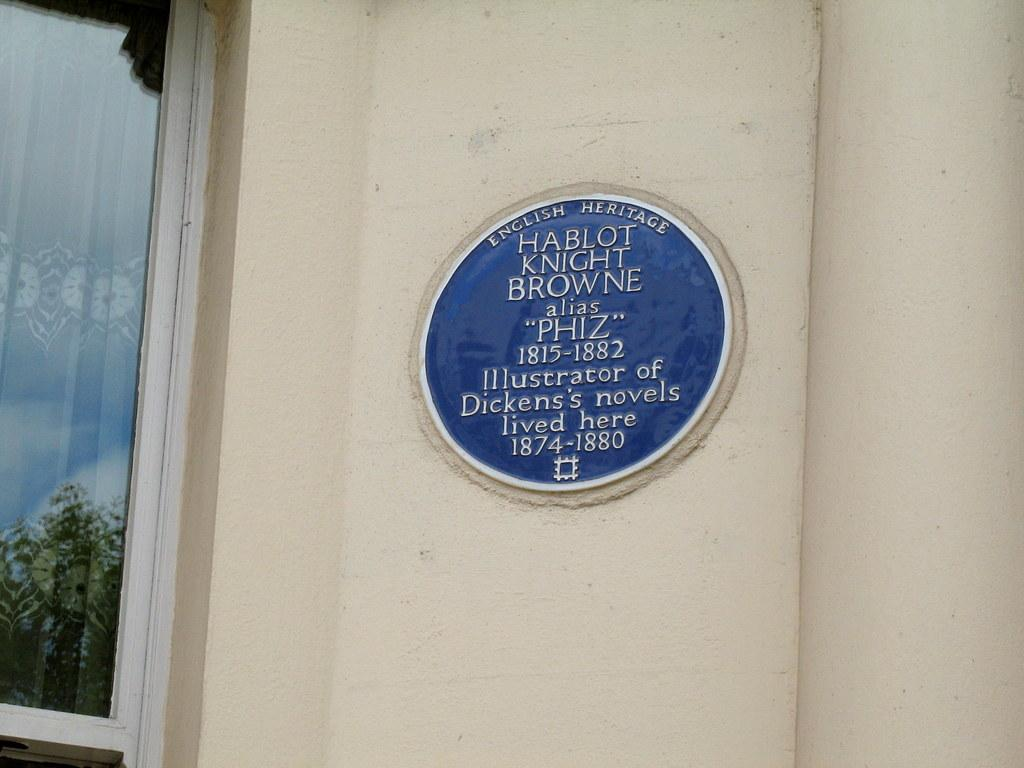What is the main structure in the image? There is a wall in the image. What is located in the middle of the wall? There is a carved stone in the middle of the wall. What object is on the left side of the wall? There is a glass on the left side of the wall. What can be seen in the glass? The reflection of a tree is visible on the glass. What type of waves can be seen crashing against the wall in the image? There are no waves present in the image; it features a wall with a carved stone and a glass with a tree reflection. 